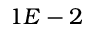<formula> <loc_0><loc_0><loc_500><loc_500>1 E - 2</formula> 